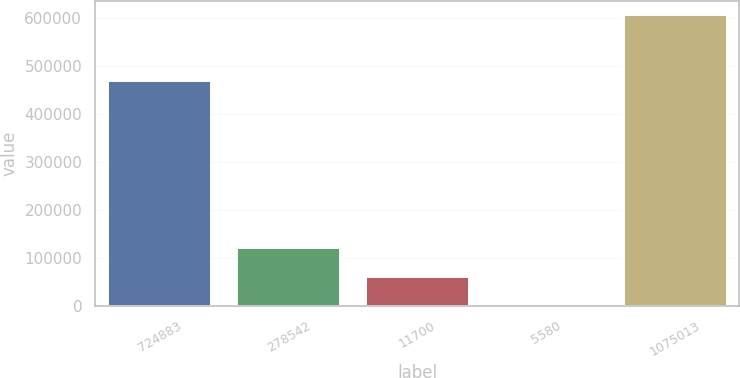<chart> <loc_0><loc_0><loc_500><loc_500><bar_chart><fcel>724883<fcel>278542<fcel>11700<fcel>5580<fcel>1075013<nl><fcel>469423<fcel>121492<fcel>60885.1<fcel>278<fcel>606349<nl></chart> 